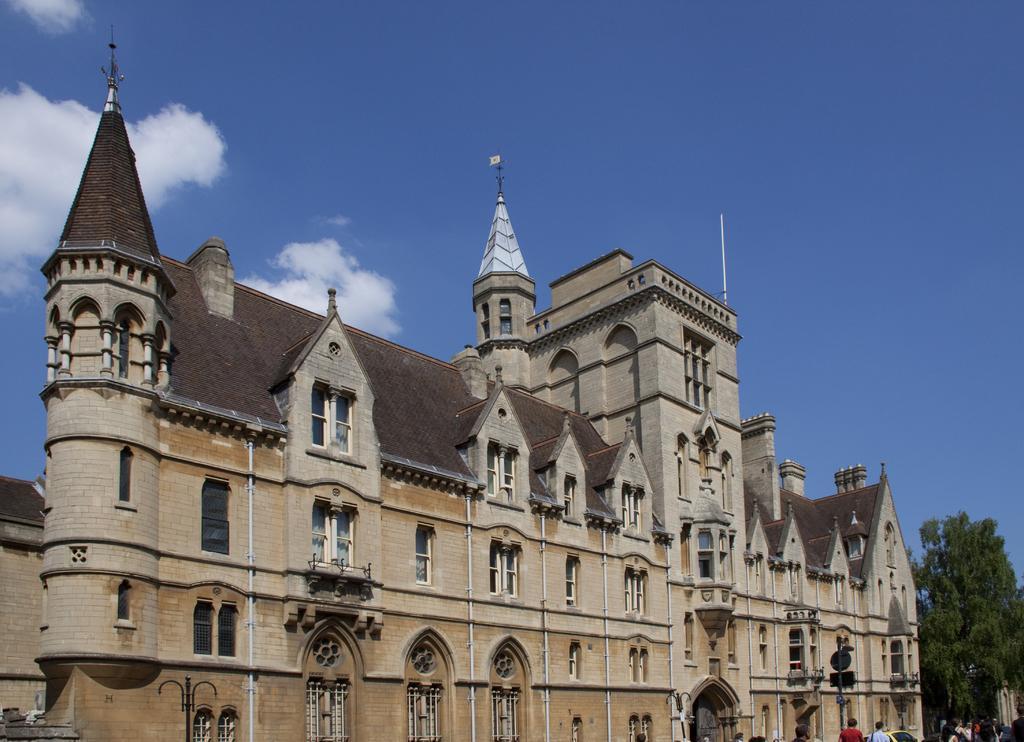Describe this image in one or two sentences. In this image I can see a building in cream and brown color. I can also see few persons walking and trees in green color and sky in blue and white color. 